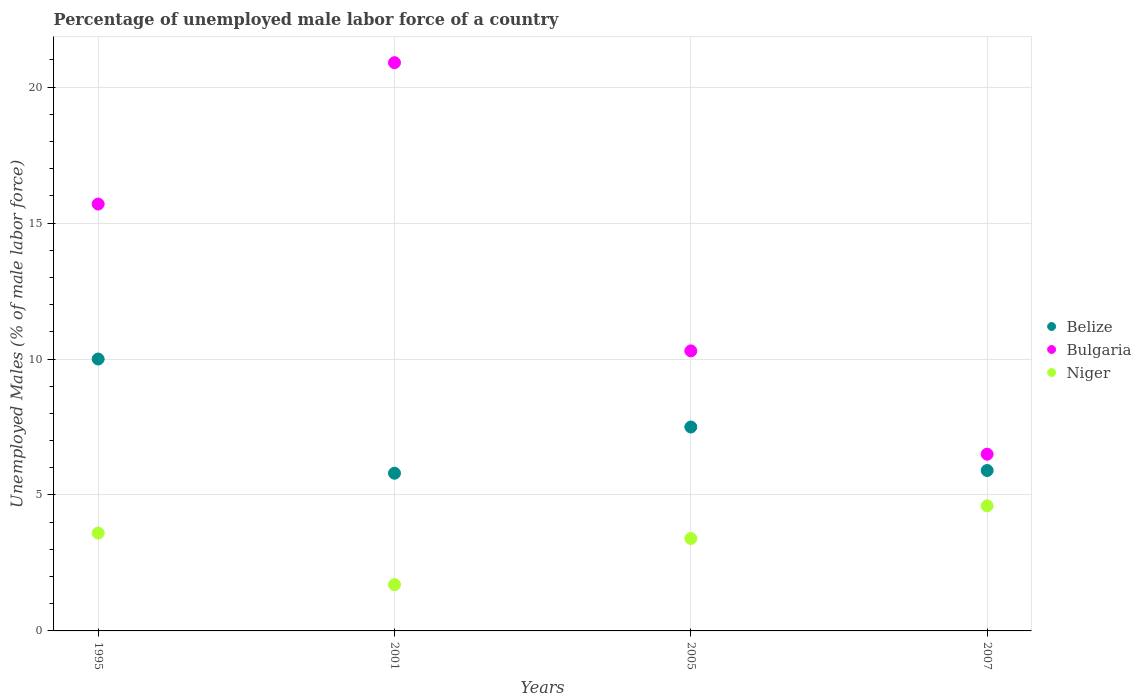How many different coloured dotlines are there?
Keep it short and to the point. 3. Is the number of dotlines equal to the number of legend labels?
Offer a terse response. Yes. Across all years, what is the maximum percentage of unemployed male labor force in Bulgaria?
Your answer should be compact. 20.9. Across all years, what is the minimum percentage of unemployed male labor force in Niger?
Ensure brevity in your answer.  1.7. In which year was the percentage of unemployed male labor force in Bulgaria minimum?
Provide a succinct answer. 2007. What is the total percentage of unemployed male labor force in Bulgaria in the graph?
Offer a very short reply. 53.4. What is the difference between the percentage of unemployed male labor force in Belize in 1995 and that in 2007?
Give a very brief answer. 4.1. What is the difference between the percentage of unemployed male labor force in Bulgaria in 2005 and the percentage of unemployed male labor force in Niger in 2001?
Offer a terse response. 8.6. What is the average percentage of unemployed male labor force in Bulgaria per year?
Your answer should be compact. 13.35. In the year 1995, what is the difference between the percentage of unemployed male labor force in Bulgaria and percentage of unemployed male labor force in Belize?
Give a very brief answer. 5.7. In how many years, is the percentage of unemployed male labor force in Bulgaria greater than 18 %?
Give a very brief answer. 1. What is the ratio of the percentage of unemployed male labor force in Bulgaria in 2005 to that in 2007?
Offer a terse response. 1.58. Is the percentage of unemployed male labor force in Belize in 1995 less than that in 2005?
Provide a short and direct response. No. Is the difference between the percentage of unemployed male labor force in Bulgaria in 1995 and 2007 greater than the difference between the percentage of unemployed male labor force in Belize in 1995 and 2007?
Provide a succinct answer. Yes. What is the difference between the highest and the second highest percentage of unemployed male labor force in Belize?
Offer a very short reply. 2.5. What is the difference between the highest and the lowest percentage of unemployed male labor force in Belize?
Offer a terse response. 4.2. In how many years, is the percentage of unemployed male labor force in Niger greater than the average percentage of unemployed male labor force in Niger taken over all years?
Offer a terse response. 3. Is the percentage of unemployed male labor force in Niger strictly greater than the percentage of unemployed male labor force in Bulgaria over the years?
Give a very brief answer. No. How many dotlines are there?
Provide a succinct answer. 3. How many years are there in the graph?
Your answer should be compact. 4. Where does the legend appear in the graph?
Make the answer very short. Center right. How many legend labels are there?
Offer a very short reply. 3. How are the legend labels stacked?
Your answer should be compact. Vertical. What is the title of the graph?
Give a very brief answer. Percentage of unemployed male labor force of a country. Does "Madagascar" appear as one of the legend labels in the graph?
Make the answer very short. No. What is the label or title of the Y-axis?
Your answer should be very brief. Unemployed Males (% of male labor force). What is the Unemployed Males (% of male labor force) in Belize in 1995?
Offer a very short reply. 10. What is the Unemployed Males (% of male labor force) in Bulgaria in 1995?
Provide a succinct answer. 15.7. What is the Unemployed Males (% of male labor force) in Niger in 1995?
Your answer should be very brief. 3.6. What is the Unemployed Males (% of male labor force) in Belize in 2001?
Your answer should be compact. 5.8. What is the Unemployed Males (% of male labor force) in Bulgaria in 2001?
Ensure brevity in your answer.  20.9. What is the Unemployed Males (% of male labor force) in Niger in 2001?
Your answer should be compact. 1.7. What is the Unemployed Males (% of male labor force) of Belize in 2005?
Your answer should be compact. 7.5. What is the Unemployed Males (% of male labor force) of Bulgaria in 2005?
Offer a terse response. 10.3. What is the Unemployed Males (% of male labor force) in Niger in 2005?
Ensure brevity in your answer.  3.4. What is the Unemployed Males (% of male labor force) in Belize in 2007?
Offer a terse response. 5.9. What is the Unemployed Males (% of male labor force) in Niger in 2007?
Ensure brevity in your answer.  4.6. Across all years, what is the maximum Unemployed Males (% of male labor force) of Bulgaria?
Your response must be concise. 20.9. Across all years, what is the maximum Unemployed Males (% of male labor force) in Niger?
Your answer should be compact. 4.6. Across all years, what is the minimum Unemployed Males (% of male labor force) in Belize?
Ensure brevity in your answer.  5.8. Across all years, what is the minimum Unemployed Males (% of male labor force) of Niger?
Give a very brief answer. 1.7. What is the total Unemployed Males (% of male labor force) of Belize in the graph?
Provide a short and direct response. 29.2. What is the total Unemployed Males (% of male labor force) in Bulgaria in the graph?
Your answer should be very brief. 53.4. What is the total Unemployed Males (% of male labor force) in Niger in the graph?
Give a very brief answer. 13.3. What is the difference between the Unemployed Males (% of male labor force) in Bulgaria in 1995 and that in 2001?
Ensure brevity in your answer.  -5.2. What is the difference between the Unemployed Males (% of male labor force) of Niger in 1995 and that in 2001?
Provide a succinct answer. 1.9. What is the difference between the Unemployed Males (% of male labor force) of Niger in 1995 and that in 2005?
Make the answer very short. 0.2. What is the difference between the Unemployed Males (% of male labor force) in Belize in 1995 and that in 2007?
Ensure brevity in your answer.  4.1. What is the difference between the Unemployed Males (% of male labor force) in Belize in 2001 and that in 2005?
Ensure brevity in your answer.  -1.7. What is the difference between the Unemployed Males (% of male labor force) in Bulgaria in 2001 and that in 2005?
Keep it short and to the point. 10.6. What is the difference between the Unemployed Males (% of male labor force) in Belize in 2001 and that in 2007?
Your answer should be compact. -0.1. What is the difference between the Unemployed Males (% of male labor force) of Niger in 2005 and that in 2007?
Make the answer very short. -1.2. What is the difference between the Unemployed Males (% of male labor force) in Belize in 1995 and the Unemployed Males (% of male labor force) in Niger in 2001?
Provide a short and direct response. 8.3. What is the difference between the Unemployed Males (% of male labor force) of Bulgaria in 1995 and the Unemployed Males (% of male labor force) of Niger in 2001?
Provide a short and direct response. 14. What is the difference between the Unemployed Males (% of male labor force) of Belize in 1995 and the Unemployed Males (% of male labor force) of Bulgaria in 2005?
Your response must be concise. -0.3. What is the difference between the Unemployed Males (% of male labor force) in Belize in 2001 and the Unemployed Males (% of male labor force) in Niger in 2005?
Your answer should be very brief. 2.4. What is the difference between the Unemployed Males (% of male labor force) in Belize in 2001 and the Unemployed Males (% of male labor force) in Bulgaria in 2007?
Ensure brevity in your answer.  -0.7. What is the difference between the Unemployed Males (% of male labor force) of Bulgaria in 2001 and the Unemployed Males (% of male labor force) of Niger in 2007?
Your response must be concise. 16.3. What is the difference between the Unemployed Males (% of male labor force) in Belize in 2005 and the Unemployed Males (% of male labor force) in Niger in 2007?
Make the answer very short. 2.9. What is the average Unemployed Males (% of male labor force) in Bulgaria per year?
Offer a terse response. 13.35. What is the average Unemployed Males (% of male labor force) in Niger per year?
Offer a very short reply. 3.33. In the year 1995, what is the difference between the Unemployed Males (% of male labor force) of Belize and Unemployed Males (% of male labor force) of Bulgaria?
Make the answer very short. -5.7. In the year 1995, what is the difference between the Unemployed Males (% of male labor force) of Belize and Unemployed Males (% of male labor force) of Niger?
Offer a terse response. 6.4. In the year 2001, what is the difference between the Unemployed Males (% of male labor force) of Belize and Unemployed Males (% of male labor force) of Bulgaria?
Your answer should be compact. -15.1. In the year 2001, what is the difference between the Unemployed Males (% of male labor force) in Belize and Unemployed Males (% of male labor force) in Niger?
Make the answer very short. 4.1. In the year 2001, what is the difference between the Unemployed Males (% of male labor force) in Bulgaria and Unemployed Males (% of male labor force) in Niger?
Offer a terse response. 19.2. In the year 2007, what is the difference between the Unemployed Males (% of male labor force) in Belize and Unemployed Males (% of male labor force) in Niger?
Ensure brevity in your answer.  1.3. What is the ratio of the Unemployed Males (% of male labor force) of Belize in 1995 to that in 2001?
Offer a very short reply. 1.72. What is the ratio of the Unemployed Males (% of male labor force) in Bulgaria in 1995 to that in 2001?
Offer a very short reply. 0.75. What is the ratio of the Unemployed Males (% of male labor force) of Niger in 1995 to that in 2001?
Your answer should be compact. 2.12. What is the ratio of the Unemployed Males (% of male labor force) in Bulgaria in 1995 to that in 2005?
Ensure brevity in your answer.  1.52. What is the ratio of the Unemployed Males (% of male labor force) in Niger in 1995 to that in 2005?
Offer a terse response. 1.06. What is the ratio of the Unemployed Males (% of male labor force) of Belize in 1995 to that in 2007?
Keep it short and to the point. 1.69. What is the ratio of the Unemployed Males (% of male labor force) of Bulgaria in 1995 to that in 2007?
Give a very brief answer. 2.42. What is the ratio of the Unemployed Males (% of male labor force) in Niger in 1995 to that in 2007?
Offer a very short reply. 0.78. What is the ratio of the Unemployed Males (% of male labor force) of Belize in 2001 to that in 2005?
Offer a very short reply. 0.77. What is the ratio of the Unemployed Males (% of male labor force) of Bulgaria in 2001 to that in 2005?
Your response must be concise. 2.03. What is the ratio of the Unemployed Males (% of male labor force) of Belize in 2001 to that in 2007?
Your response must be concise. 0.98. What is the ratio of the Unemployed Males (% of male labor force) in Bulgaria in 2001 to that in 2007?
Your answer should be compact. 3.22. What is the ratio of the Unemployed Males (% of male labor force) in Niger in 2001 to that in 2007?
Offer a terse response. 0.37. What is the ratio of the Unemployed Males (% of male labor force) of Belize in 2005 to that in 2007?
Keep it short and to the point. 1.27. What is the ratio of the Unemployed Males (% of male labor force) of Bulgaria in 2005 to that in 2007?
Your answer should be compact. 1.58. What is the ratio of the Unemployed Males (% of male labor force) of Niger in 2005 to that in 2007?
Offer a terse response. 0.74. What is the difference between the highest and the lowest Unemployed Males (% of male labor force) in Belize?
Your answer should be compact. 4.2. What is the difference between the highest and the lowest Unemployed Males (% of male labor force) in Bulgaria?
Keep it short and to the point. 14.4. 